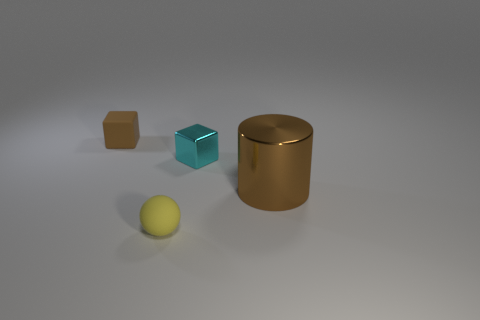What is the texture of the largest object in the image? The largest object appears to have a smooth, reflective surface with a matte finish that diffuses the light, giving a soft appearance. 